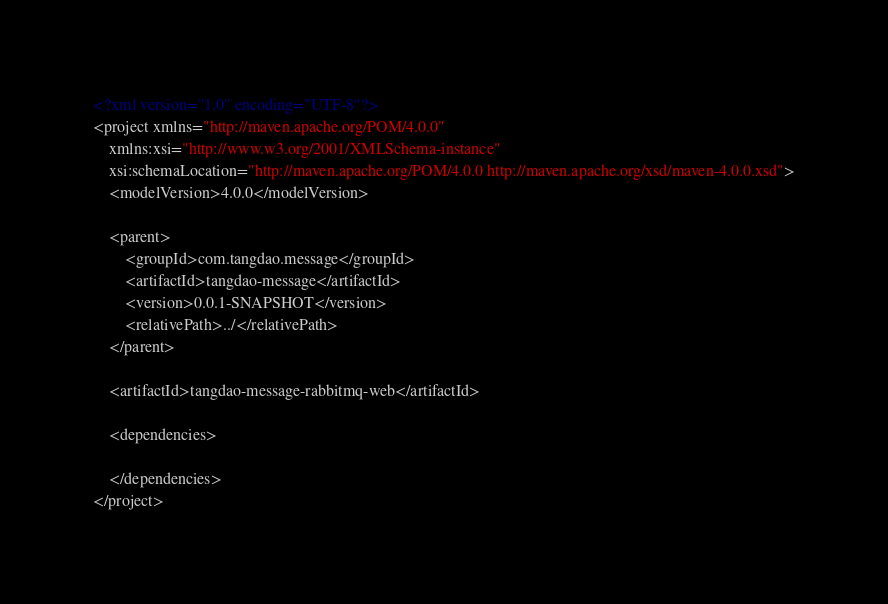<code> <loc_0><loc_0><loc_500><loc_500><_XML_><?xml version="1.0" encoding="UTF-8"?>
<project xmlns="http://maven.apache.org/POM/4.0.0"
	xmlns:xsi="http://www.w3.org/2001/XMLSchema-instance"
	xsi:schemaLocation="http://maven.apache.org/POM/4.0.0 http://maven.apache.org/xsd/maven-4.0.0.xsd">
	<modelVersion>4.0.0</modelVersion>

	<parent>
		<groupId>com.tangdao.message</groupId>
		<artifactId>tangdao-message</artifactId>
		<version>0.0.1-SNAPSHOT</version>
		<relativePath>../</relativePath>
	</parent>

	<artifactId>tangdao-message-rabbitmq-web</artifactId>

	<dependencies>
	
	</dependencies>
</project></code> 